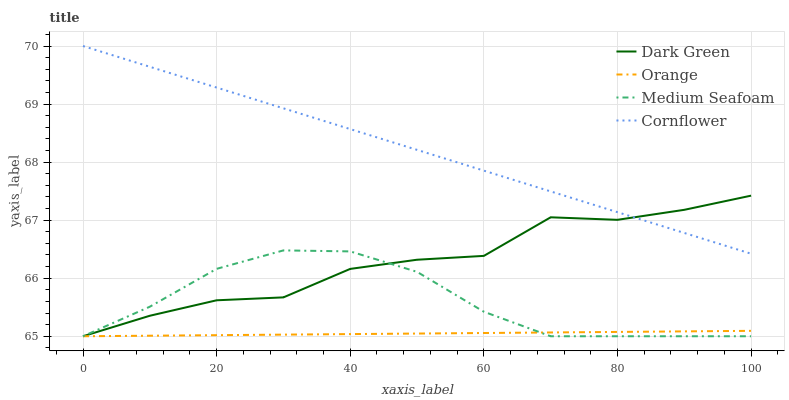Does Orange have the minimum area under the curve?
Answer yes or no. Yes. Does Cornflower have the maximum area under the curve?
Answer yes or no. Yes. Does Medium Seafoam have the minimum area under the curve?
Answer yes or no. No. Does Medium Seafoam have the maximum area under the curve?
Answer yes or no. No. Is Orange the smoothest?
Answer yes or no. Yes. Is Dark Green the roughest?
Answer yes or no. Yes. Is Cornflower the smoothest?
Answer yes or no. No. Is Cornflower the roughest?
Answer yes or no. No. Does Orange have the lowest value?
Answer yes or no. Yes. Does Cornflower have the lowest value?
Answer yes or no. No. Does Cornflower have the highest value?
Answer yes or no. Yes. Does Medium Seafoam have the highest value?
Answer yes or no. No. Is Orange less than Cornflower?
Answer yes or no. Yes. Is Cornflower greater than Medium Seafoam?
Answer yes or no. Yes. Does Dark Green intersect Cornflower?
Answer yes or no. Yes. Is Dark Green less than Cornflower?
Answer yes or no. No. Is Dark Green greater than Cornflower?
Answer yes or no. No. Does Orange intersect Cornflower?
Answer yes or no. No. 